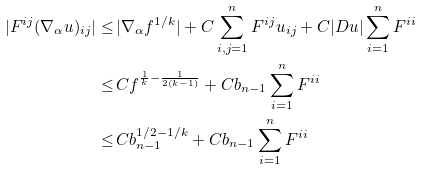Convert formula to latex. <formula><loc_0><loc_0><loc_500><loc_500>| F ^ { i j } ( \nabla _ { \alpha } u ) _ { i j } | \leq \, & | \nabla _ { \alpha } f ^ { 1 / k } | + C \sum _ { i , j = 1 } ^ { n } F ^ { i j } u _ { i j } + C | D u | \sum _ { i = 1 } ^ { n } F ^ { i i } \\ \leq \, & C f ^ { \frac { 1 } { k } - \frac { 1 } { 2 ( k - 1 ) } } + C b _ { n - 1 } \sum _ { i = 1 } ^ { n } F ^ { i i } \\ \leq \, & C b _ { n - 1 } ^ { 1 / 2 - 1 / k } + C b _ { n - 1 } \sum _ { i = 1 } ^ { n } F ^ { i i }</formula> 